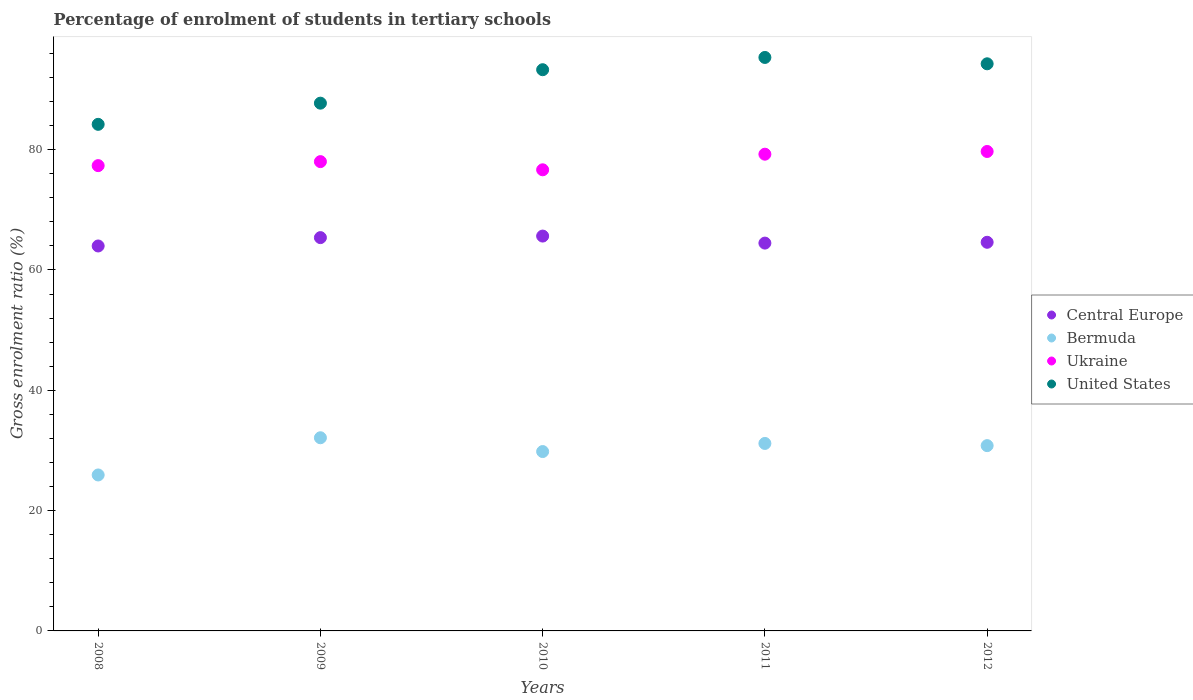How many different coloured dotlines are there?
Make the answer very short. 4. What is the percentage of students enrolled in tertiary schools in United States in 2010?
Ensure brevity in your answer.  93.29. Across all years, what is the maximum percentage of students enrolled in tertiary schools in Central Europe?
Your response must be concise. 65.64. Across all years, what is the minimum percentage of students enrolled in tertiary schools in United States?
Provide a short and direct response. 84.21. In which year was the percentage of students enrolled in tertiary schools in Central Europe minimum?
Offer a terse response. 2008. What is the total percentage of students enrolled in tertiary schools in United States in the graph?
Provide a succinct answer. 454.85. What is the difference between the percentage of students enrolled in tertiary schools in United States in 2008 and that in 2012?
Offer a terse response. -10.06. What is the difference between the percentage of students enrolled in tertiary schools in Bermuda in 2012 and the percentage of students enrolled in tertiary schools in United States in 2010?
Ensure brevity in your answer.  -62.49. What is the average percentage of students enrolled in tertiary schools in Bermuda per year?
Offer a terse response. 29.96. In the year 2010, what is the difference between the percentage of students enrolled in tertiary schools in Central Europe and percentage of students enrolled in tertiary schools in Bermuda?
Offer a very short reply. 35.82. What is the ratio of the percentage of students enrolled in tertiary schools in United States in 2009 to that in 2012?
Offer a very short reply. 0.93. Is the percentage of students enrolled in tertiary schools in Bermuda in 2009 less than that in 2010?
Make the answer very short. No. Is the difference between the percentage of students enrolled in tertiary schools in Central Europe in 2009 and 2011 greater than the difference between the percentage of students enrolled in tertiary schools in Bermuda in 2009 and 2011?
Provide a short and direct response. No. What is the difference between the highest and the second highest percentage of students enrolled in tertiary schools in Central Europe?
Provide a succinct answer. 0.26. What is the difference between the highest and the lowest percentage of students enrolled in tertiary schools in Ukraine?
Provide a succinct answer. 3.05. Is the sum of the percentage of students enrolled in tertiary schools in Bermuda in 2010 and 2011 greater than the maximum percentage of students enrolled in tertiary schools in Central Europe across all years?
Make the answer very short. No. Is it the case that in every year, the sum of the percentage of students enrolled in tertiary schools in United States and percentage of students enrolled in tertiary schools in Ukraine  is greater than the percentage of students enrolled in tertiary schools in Bermuda?
Your response must be concise. Yes. Does the percentage of students enrolled in tertiary schools in Central Europe monotonically increase over the years?
Offer a terse response. No. Is the percentage of students enrolled in tertiary schools in United States strictly greater than the percentage of students enrolled in tertiary schools in Ukraine over the years?
Offer a very short reply. Yes. How many dotlines are there?
Ensure brevity in your answer.  4. What is the difference between two consecutive major ticks on the Y-axis?
Provide a succinct answer. 20. Where does the legend appear in the graph?
Give a very brief answer. Center right. How many legend labels are there?
Your answer should be very brief. 4. How are the legend labels stacked?
Provide a short and direct response. Vertical. What is the title of the graph?
Provide a short and direct response. Percentage of enrolment of students in tertiary schools. Does "Korea (Democratic)" appear as one of the legend labels in the graph?
Your answer should be very brief. No. What is the label or title of the Y-axis?
Keep it short and to the point. Gross enrolment ratio (%). What is the Gross enrolment ratio (%) in Central Europe in 2008?
Your response must be concise. 63.99. What is the Gross enrolment ratio (%) in Bermuda in 2008?
Your response must be concise. 25.93. What is the Gross enrolment ratio (%) in Ukraine in 2008?
Offer a terse response. 77.35. What is the Gross enrolment ratio (%) of United States in 2008?
Your answer should be very brief. 84.21. What is the Gross enrolment ratio (%) in Central Europe in 2009?
Offer a very short reply. 65.38. What is the Gross enrolment ratio (%) in Bermuda in 2009?
Make the answer very short. 32.11. What is the Gross enrolment ratio (%) in Ukraine in 2009?
Make the answer very short. 78.01. What is the Gross enrolment ratio (%) in United States in 2009?
Your response must be concise. 87.73. What is the Gross enrolment ratio (%) in Central Europe in 2010?
Make the answer very short. 65.64. What is the Gross enrolment ratio (%) in Bermuda in 2010?
Your answer should be very brief. 29.82. What is the Gross enrolment ratio (%) of Ukraine in 2010?
Ensure brevity in your answer.  76.66. What is the Gross enrolment ratio (%) in United States in 2010?
Provide a short and direct response. 93.29. What is the Gross enrolment ratio (%) in Central Europe in 2011?
Provide a succinct answer. 64.47. What is the Gross enrolment ratio (%) in Bermuda in 2011?
Provide a succinct answer. 31.17. What is the Gross enrolment ratio (%) of Ukraine in 2011?
Your answer should be very brief. 79.25. What is the Gross enrolment ratio (%) of United States in 2011?
Give a very brief answer. 95.33. What is the Gross enrolment ratio (%) of Central Europe in 2012?
Your answer should be very brief. 64.61. What is the Gross enrolment ratio (%) of Bermuda in 2012?
Provide a succinct answer. 30.8. What is the Gross enrolment ratio (%) in Ukraine in 2012?
Ensure brevity in your answer.  79.7. What is the Gross enrolment ratio (%) of United States in 2012?
Offer a very short reply. 94.28. Across all years, what is the maximum Gross enrolment ratio (%) in Central Europe?
Provide a short and direct response. 65.64. Across all years, what is the maximum Gross enrolment ratio (%) of Bermuda?
Keep it short and to the point. 32.11. Across all years, what is the maximum Gross enrolment ratio (%) of Ukraine?
Offer a terse response. 79.7. Across all years, what is the maximum Gross enrolment ratio (%) in United States?
Ensure brevity in your answer.  95.33. Across all years, what is the minimum Gross enrolment ratio (%) of Central Europe?
Give a very brief answer. 63.99. Across all years, what is the minimum Gross enrolment ratio (%) of Bermuda?
Offer a very short reply. 25.93. Across all years, what is the minimum Gross enrolment ratio (%) in Ukraine?
Provide a succinct answer. 76.66. Across all years, what is the minimum Gross enrolment ratio (%) of United States?
Keep it short and to the point. 84.21. What is the total Gross enrolment ratio (%) in Central Europe in the graph?
Give a very brief answer. 324.09. What is the total Gross enrolment ratio (%) in Bermuda in the graph?
Provide a short and direct response. 149.82. What is the total Gross enrolment ratio (%) in Ukraine in the graph?
Keep it short and to the point. 390.97. What is the total Gross enrolment ratio (%) of United States in the graph?
Make the answer very short. 454.85. What is the difference between the Gross enrolment ratio (%) in Central Europe in 2008 and that in 2009?
Provide a succinct answer. -1.39. What is the difference between the Gross enrolment ratio (%) in Bermuda in 2008 and that in 2009?
Your response must be concise. -6.18. What is the difference between the Gross enrolment ratio (%) of Ukraine in 2008 and that in 2009?
Give a very brief answer. -0.67. What is the difference between the Gross enrolment ratio (%) of United States in 2008 and that in 2009?
Your answer should be very brief. -3.52. What is the difference between the Gross enrolment ratio (%) in Central Europe in 2008 and that in 2010?
Your response must be concise. -1.65. What is the difference between the Gross enrolment ratio (%) of Bermuda in 2008 and that in 2010?
Offer a very short reply. -3.89. What is the difference between the Gross enrolment ratio (%) of Ukraine in 2008 and that in 2010?
Offer a very short reply. 0.69. What is the difference between the Gross enrolment ratio (%) of United States in 2008 and that in 2010?
Provide a succinct answer. -9.08. What is the difference between the Gross enrolment ratio (%) in Central Europe in 2008 and that in 2011?
Your response must be concise. -0.48. What is the difference between the Gross enrolment ratio (%) of Bermuda in 2008 and that in 2011?
Give a very brief answer. -5.24. What is the difference between the Gross enrolment ratio (%) in Ukraine in 2008 and that in 2011?
Ensure brevity in your answer.  -1.9. What is the difference between the Gross enrolment ratio (%) in United States in 2008 and that in 2011?
Your answer should be very brief. -11.12. What is the difference between the Gross enrolment ratio (%) of Central Europe in 2008 and that in 2012?
Offer a terse response. -0.61. What is the difference between the Gross enrolment ratio (%) of Bermuda in 2008 and that in 2012?
Give a very brief answer. -4.88. What is the difference between the Gross enrolment ratio (%) of Ukraine in 2008 and that in 2012?
Give a very brief answer. -2.35. What is the difference between the Gross enrolment ratio (%) of United States in 2008 and that in 2012?
Provide a short and direct response. -10.06. What is the difference between the Gross enrolment ratio (%) in Central Europe in 2009 and that in 2010?
Your answer should be compact. -0.26. What is the difference between the Gross enrolment ratio (%) of Bermuda in 2009 and that in 2010?
Your answer should be very brief. 2.29. What is the difference between the Gross enrolment ratio (%) of Ukraine in 2009 and that in 2010?
Provide a succinct answer. 1.36. What is the difference between the Gross enrolment ratio (%) of United States in 2009 and that in 2010?
Provide a succinct answer. -5.56. What is the difference between the Gross enrolment ratio (%) of Central Europe in 2009 and that in 2011?
Provide a short and direct response. 0.91. What is the difference between the Gross enrolment ratio (%) in Bermuda in 2009 and that in 2011?
Ensure brevity in your answer.  0.95. What is the difference between the Gross enrolment ratio (%) of Ukraine in 2009 and that in 2011?
Your response must be concise. -1.23. What is the difference between the Gross enrolment ratio (%) in United States in 2009 and that in 2011?
Offer a terse response. -7.6. What is the difference between the Gross enrolment ratio (%) in Central Europe in 2009 and that in 2012?
Ensure brevity in your answer.  0.78. What is the difference between the Gross enrolment ratio (%) of Bermuda in 2009 and that in 2012?
Keep it short and to the point. 1.31. What is the difference between the Gross enrolment ratio (%) in Ukraine in 2009 and that in 2012?
Give a very brief answer. -1.69. What is the difference between the Gross enrolment ratio (%) of United States in 2009 and that in 2012?
Make the answer very short. -6.54. What is the difference between the Gross enrolment ratio (%) in Central Europe in 2010 and that in 2011?
Ensure brevity in your answer.  1.17. What is the difference between the Gross enrolment ratio (%) in Bermuda in 2010 and that in 2011?
Your answer should be very brief. -1.35. What is the difference between the Gross enrolment ratio (%) of Ukraine in 2010 and that in 2011?
Offer a terse response. -2.59. What is the difference between the Gross enrolment ratio (%) in United States in 2010 and that in 2011?
Your response must be concise. -2.04. What is the difference between the Gross enrolment ratio (%) of Central Europe in 2010 and that in 2012?
Make the answer very short. 1.03. What is the difference between the Gross enrolment ratio (%) in Bermuda in 2010 and that in 2012?
Offer a very short reply. -0.99. What is the difference between the Gross enrolment ratio (%) of Ukraine in 2010 and that in 2012?
Offer a terse response. -3.05. What is the difference between the Gross enrolment ratio (%) in United States in 2010 and that in 2012?
Make the answer very short. -0.98. What is the difference between the Gross enrolment ratio (%) of Central Europe in 2011 and that in 2012?
Offer a very short reply. -0.14. What is the difference between the Gross enrolment ratio (%) of Bermuda in 2011 and that in 2012?
Provide a succinct answer. 0.36. What is the difference between the Gross enrolment ratio (%) of Ukraine in 2011 and that in 2012?
Your response must be concise. -0.45. What is the difference between the Gross enrolment ratio (%) of United States in 2011 and that in 2012?
Your response must be concise. 1.06. What is the difference between the Gross enrolment ratio (%) of Central Europe in 2008 and the Gross enrolment ratio (%) of Bermuda in 2009?
Your response must be concise. 31.88. What is the difference between the Gross enrolment ratio (%) in Central Europe in 2008 and the Gross enrolment ratio (%) in Ukraine in 2009?
Offer a very short reply. -14.02. What is the difference between the Gross enrolment ratio (%) in Central Europe in 2008 and the Gross enrolment ratio (%) in United States in 2009?
Your answer should be compact. -23.74. What is the difference between the Gross enrolment ratio (%) of Bermuda in 2008 and the Gross enrolment ratio (%) of Ukraine in 2009?
Provide a short and direct response. -52.09. What is the difference between the Gross enrolment ratio (%) of Bermuda in 2008 and the Gross enrolment ratio (%) of United States in 2009?
Your answer should be compact. -61.81. What is the difference between the Gross enrolment ratio (%) of Ukraine in 2008 and the Gross enrolment ratio (%) of United States in 2009?
Provide a succinct answer. -10.38. What is the difference between the Gross enrolment ratio (%) in Central Europe in 2008 and the Gross enrolment ratio (%) in Bermuda in 2010?
Provide a short and direct response. 34.17. What is the difference between the Gross enrolment ratio (%) of Central Europe in 2008 and the Gross enrolment ratio (%) of Ukraine in 2010?
Your answer should be compact. -12.66. What is the difference between the Gross enrolment ratio (%) in Central Europe in 2008 and the Gross enrolment ratio (%) in United States in 2010?
Make the answer very short. -29.3. What is the difference between the Gross enrolment ratio (%) in Bermuda in 2008 and the Gross enrolment ratio (%) in Ukraine in 2010?
Your answer should be compact. -50.73. What is the difference between the Gross enrolment ratio (%) in Bermuda in 2008 and the Gross enrolment ratio (%) in United States in 2010?
Your answer should be compact. -67.37. What is the difference between the Gross enrolment ratio (%) in Ukraine in 2008 and the Gross enrolment ratio (%) in United States in 2010?
Offer a very short reply. -15.94. What is the difference between the Gross enrolment ratio (%) of Central Europe in 2008 and the Gross enrolment ratio (%) of Bermuda in 2011?
Offer a terse response. 32.83. What is the difference between the Gross enrolment ratio (%) of Central Europe in 2008 and the Gross enrolment ratio (%) of Ukraine in 2011?
Make the answer very short. -15.26. What is the difference between the Gross enrolment ratio (%) in Central Europe in 2008 and the Gross enrolment ratio (%) in United States in 2011?
Offer a very short reply. -31.34. What is the difference between the Gross enrolment ratio (%) in Bermuda in 2008 and the Gross enrolment ratio (%) in Ukraine in 2011?
Offer a terse response. -53.32. What is the difference between the Gross enrolment ratio (%) in Bermuda in 2008 and the Gross enrolment ratio (%) in United States in 2011?
Offer a very short reply. -69.41. What is the difference between the Gross enrolment ratio (%) in Ukraine in 2008 and the Gross enrolment ratio (%) in United States in 2011?
Keep it short and to the point. -17.98. What is the difference between the Gross enrolment ratio (%) of Central Europe in 2008 and the Gross enrolment ratio (%) of Bermuda in 2012?
Provide a short and direct response. 33.19. What is the difference between the Gross enrolment ratio (%) in Central Europe in 2008 and the Gross enrolment ratio (%) in Ukraine in 2012?
Provide a succinct answer. -15.71. What is the difference between the Gross enrolment ratio (%) in Central Europe in 2008 and the Gross enrolment ratio (%) in United States in 2012?
Your response must be concise. -30.29. What is the difference between the Gross enrolment ratio (%) in Bermuda in 2008 and the Gross enrolment ratio (%) in Ukraine in 2012?
Your answer should be compact. -53.78. What is the difference between the Gross enrolment ratio (%) of Bermuda in 2008 and the Gross enrolment ratio (%) of United States in 2012?
Offer a very short reply. -68.35. What is the difference between the Gross enrolment ratio (%) of Ukraine in 2008 and the Gross enrolment ratio (%) of United States in 2012?
Ensure brevity in your answer.  -16.93. What is the difference between the Gross enrolment ratio (%) of Central Europe in 2009 and the Gross enrolment ratio (%) of Bermuda in 2010?
Give a very brief answer. 35.56. What is the difference between the Gross enrolment ratio (%) of Central Europe in 2009 and the Gross enrolment ratio (%) of Ukraine in 2010?
Provide a succinct answer. -11.27. What is the difference between the Gross enrolment ratio (%) of Central Europe in 2009 and the Gross enrolment ratio (%) of United States in 2010?
Offer a very short reply. -27.91. What is the difference between the Gross enrolment ratio (%) in Bermuda in 2009 and the Gross enrolment ratio (%) in Ukraine in 2010?
Give a very brief answer. -44.54. What is the difference between the Gross enrolment ratio (%) in Bermuda in 2009 and the Gross enrolment ratio (%) in United States in 2010?
Give a very brief answer. -61.18. What is the difference between the Gross enrolment ratio (%) in Ukraine in 2009 and the Gross enrolment ratio (%) in United States in 2010?
Your answer should be very brief. -15.28. What is the difference between the Gross enrolment ratio (%) of Central Europe in 2009 and the Gross enrolment ratio (%) of Bermuda in 2011?
Offer a terse response. 34.22. What is the difference between the Gross enrolment ratio (%) of Central Europe in 2009 and the Gross enrolment ratio (%) of Ukraine in 2011?
Your answer should be compact. -13.87. What is the difference between the Gross enrolment ratio (%) in Central Europe in 2009 and the Gross enrolment ratio (%) in United States in 2011?
Offer a terse response. -29.95. What is the difference between the Gross enrolment ratio (%) in Bermuda in 2009 and the Gross enrolment ratio (%) in Ukraine in 2011?
Provide a short and direct response. -47.14. What is the difference between the Gross enrolment ratio (%) of Bermuda in 2009 and the Gross enrolment ratio (%) of United States in 2011?
Your answer should be compact. -63.22. What is the difference between the Gross enrolment ratio (%) in Ukraine in 2009 and the Gross enrolment ratio (%) in United States in 2011?
Ensure brevity in your answer.  -17.32. What is the difference between the Gross enrolment ratio (%) of Central Europe in 2009 and the Gross enrolment ratio (%) of Bermuda in 2012?
Provide a short and direct response. 34.58. What is the difference between the Gross enrolment ratio (%) in Central Europe in 2009 and the Gross enrolment ratio (%) in Ukraine in 2012?
Your response must be concise. -14.32. What is the difference between the Gross enrolment ratio (%) in Central Europe in 2009 and the Gross enrolment ratio (%) in United States in 2012?
Your answer should be compact. -28.9. What is the difference between the Gross enrolment ratio (%) of Bermuda in 2009 and the Gross enrolment ratio (%) of Ukraine in 2012?
Your answer should be compact. -47.59. What is the difference between the Gross enrolment ratio (%) in Bermuda in 2009 and the Gross enrolment ratio (%) in United States in 2012?
Your answer should be very brief. -62.17. What is the difference between the Gross enrolment ratio (%) of Ukraine in 2009 and the Gross enrolment ratio (%) of United States in 2012?
Ensure brevity in your answer.  -16.26. What is the difference between the Gross enrolment ratio (%) of Central Europe in 2010 and the Gross enrolment ratio (%) of Bermuda in 2011?
Ensure brevity in your answer.  34.47. What is the difference between the Gross enrolment ratio (%) of Central Europe in 2010 and the Gross enrolment ratio (%) of Ukraine in 2011?
Make the answer very short. -13.61. What is the difference between the Gross enrolment ratio (%) of Central Europe in 2010 and the Gross enrolment ratio (%) of United States in 2011?
Offer a terse response. -29.69. What is the difference between the Gross enrolment ratio (%) of Bermuda in 2010 and the Gross enrolment ratio (%) of Ukraine in 2011?
Make the answer very short. -49.43. What is the difference between the Gross enrolment ratio (%) of Bermuda in 2010 and the Gross enrolment ratio (%) of United States in 2011?
Your answer should be very brief. -65.52. What is the difference between the Gross enrolment ratio (%) in Ukraine in 2010 and the Gross enrolment ratio (%) in United States in 2011?
Offer a very short reply. -18.68. What is the difference between the Gross enrolment ratio (%) of Central Europe in 2010 and the Gross enrolment ratio (%) of Bermuda in 2012?
Your answer should be very brief. 34.84. What is the difference between the Gross enrolment ratio (%) in Central Europe in 2010 and the Gross enrolment ratio (%) in Ukraine in 2012?
Your answer should be compact. -14.06. What is the difference between the Gross enrolment ratio (%) of Central Europe in 2010 and the Gross enrolment ratio (%) of United States in 2012?
Give a very brief answer. -28.64. What is the difference between the Gross enrolment ratio (%) of Bermuda in 2010 and the Gross enrolment ratio (%) of Ukraine in 2012?
Offer a terse response. -49.88. What is the difference between the Gross enrolment ratio (%) in Bermuda in 2010 and the Gross enrolment ratio (%) in United States in 2012?
Give a very brief answer. -64.46. What is the difference between the Gross enrolment ratio (%) of Ukraine in 2010 and the Gross enrolment ratio (%) of United States in 2012?
Ensure brevity in your answer.  -17.62. What is the difference between the Gross enrolment ratio (%) of Central Europe in 2011 and the Gross enrolment ratio (%) of Bermuda in 2012?
Give a very brief answer. 33.67. What is the difference between the Gross enrolment ratio (%) of Central Europe in 2011 and the Gross enrolment ratio (%) of Ukraine in 2012?
Keep it short and to the point. -15.23. What is the difference between the Gross enrolment ratio (%) in Central Europe in 2011 and the Gross enrolment ratio (%) in United States in 2012?
Make the answer very short. -29.81. What is the difference between the Gross enrolment ratio (%) of Bermuda in 2011 and the Gross enrolment ratio (%) of Ukraine in 2012?
Your answer should be compact. -48.54. What is the difference between the Gross enrolment ratio (%) of Bermuda in 2011 and the Gross enrolment ratio (%) of United States in 2012?
Ensure brevity in your answer.  -63.11. What is the difference between the Gross enrolment ratio (%) in Ukraine in 2011 and the Gross enrolment ratio (%) in United States in 2012?
Your answer should be very brief. -15.03. What is the average Gross enrolment ratio (%) in Central Europe per year?
Keep it short and to the point. 64.82. What is the average Gross enrolment ratio (%) of Bermuda per year?
Provide a short and direct response. 29.96. What is the average Gross enrolment ratio (%) of Ukraine per year?
Your answer should be compact. 78.19. What is the average Gross enrolment ratio (%) in United States per year?
Give a very brief answer. 90.97. In the year 2008, what is the difference between the Gross enrolment ratio (%) of Central Europe and Gross enrolment ratio (%) of Bermuda?
Keep it short and to the point. 38.07. In the year 2008, what is the difference between the Gross enrolment ratio (%) of Central Europe and Gross enrolment ratio (%) of Ukraine?
Offer a terse response. -13.36. In the year 2008, what is the difference between the Gross enrolment ratio (%) of Central Europe and Gross enrolment ratio (%) of United States?
Your response must be concise. -20.22. In the year 2008, what is the difference between the Gross enrolment ratio (%) in Bermuda and Gross enrolment ratio (%) in Ukraine?
Your answer should be very brief. -51.42. In the year 2008, what is the difference between the Gross enrolment ratio (%) of Bermuda and Gross enrolment ratio (%) of United States?
Keep it short and to the point. -58.29. In the year 2008, what is the difference between the Gross enrolment ratio (%) in Ukraine and Gross enrolment ratio (%) in United States?
Provide a short and direct response. -6.86. In the year 2009, what is the difference between the Gross enrolment ratio (%) in Central Europe and Gross enrolment ratio (%) in Bermuda?
Your answer should be very brief. 33.27. In the year 2009, what is the difference between the Gross enrolment ratio (%) in Central Europe and Gross enrolment ratio (%) in Ukraine?
Provide a short and direct response. -12.63. In the year 2009, what is the difference between the Gross enrolment ratio (%) in Central Europe and Gross enrolment ratio (%) in United States?
Provide a succinct answer. -22.35. In the year 2009, what is the difference between the Gross enrolment ratio (%) of Bermuda and Gross enrolment ratio (%) of Ukraine?
Keep it short and to the point. -45.9. In the year 2009, what is the difference between the Gross enrolment ratio (%) in Bermuda and Gross enrolment ratio (%) in United States?
Give a very brief answer. -55.62. In the year 2009, what is the difference between the Gross enrolment ratio (%) of Ukraine and Gross enrolment ratio (%) of United States?
Make the answer very short. -9.72. In the year 2010, what is the difference between the Gross enrolment ratio (%) of Central Europe and Gross enrolment ratio (%) of Bermuda?
Provide a short and direct response. 35.82. In the year 2010, what is the difference between the Gross enrolment ratio (%) of Central Europe and Gross enrolment ratio (%) of Ukraine?
Your response must be concise. -11.02. In the year 2010, what is the difference between the Gross enrolment ratio (%) in Central Europe and Gross enrolment ratio (%) in United States?
Offer a terse response. -27.65. In the year 2010, what is the difference between the Gross enrolment ratio (%) in Bermuda and Gross enrolment ratio (%) in Ukraine?
Your answer should be compact. -46.84. In the year 2010, what is the difference between the Gross enrolment ratio (%) in Bermuda and Gross enrolment ratio (%) in United States?
Offer a very short reply. -63.48. In the year 2010, what is the difference between the Gross enrolment ratio (%) of Ukraine and Gross enrolment ratio (%) of United States?
Your answer should be compact. -16.64. In the year 2011, what is the difference between the Gross enrolment ratio (%) in Central Europe and Gross enrolment ratio (%) in Bermuda?
Keep it short and to the point. 33.3. In the year 2011, what is the difference between the Gross enrolment ratio (%) of Central Europe and Gross enrolment ratio (%) of Ukraine?
Offer a very short reply. -14.78. In the year 2011, what is the difference between the Gross enrolment ratio (%) of Central Europe and Gross enrolment ratio (%) of United States?
Offer a terse response. -30.86. In the year 2011, what is the difference between the Gross enrolment ratio (%) in Bermuda and Gross enrolment ratio (%) in Ukraine?
Your response must be concise. -48.08. In the year 2011, what is the difference between the Gross enrolment ratio (%) of Bermuda and Gross enrolment ratio (%) of United States?
Make the answer very short. -64.17. In the year 2011, what is the difference between the Gross enrolment ratio (%) in Ukraine and Gross enrolment ratio (%) in United States?
Ensure brevity in your answer.  -16.08. In the year 2012, what is the difference between the Gross enrolment ratio (%) in Central Europe and Gross enrolment ratio (%) in Bermuda?
Your response must be concise. 33.8. In the year 2012, what is the difference between the Gross enrolment ratio (%) in Central Europe and Gross enrolment ratio (%) in Ukraine?
Your response must be concise. -15.1. In the year 2012, what is the difference between the Gross enrolment ratio (%) in Central Europe and Gross enrolment ratio (%) in United States?
Ensure brevity in your answer.  -29.67. In the year 2012, what is the difference between the Gross enrolment ratio (%) in Bermuda and Gross enrolment ratio (%) in Ukraine?
Provide a short and direct response. -48.9. In the year 2012, what is the difference between the Gross enrolment ratio (%) of Bermuda and Gross enrolment ratio (%) of United States?
Ensure brevity in your answer.  -63.47. In the year 2012, what is the difference between the Gross enrolment ratio (%) of Ukraine and Gross enrolment ratio (%) of United States?
Your response must be concise. -14.58. What is the ratio of the Gross enrolment ratio (%) in Central Europe in 2008 to that in 2009?
Provide a succinct answer. 0.98. What is the ratio of the Gross enrolment ratio (%) of Bermuda in 2008 to that in 2009?
Provide a succinct answer. 0.81. What is the ratio of the Gross enrolment ratio (%) of Ukraine in 2008 to that in 2009?
Your answer should be compact. 0.99. What is the ratio of the Gross enrolment ratio (%) of United States in 2008 to that in 2009?
Offer a terse response. 0.96. What is the ratio of the Gross enrolment ratio (%) in Central Europe in 2008 to that in 2010?
Make the answer very short. 0.97. What is the ratio of the Gross enrolment ratio (%) of Bermuda in 2008 to that in 2010?
Offer a very short reply. 0.87. What is the ratio of the Gross enrolment ratio (%) of Ukraine in 2008 to that in 2010?
Keep it short and to the point. 1.01. What is the ratio of the Gross enrolment ratio (%) of United States in 2008 to that in 2010?
Make the answer very short. 0.9. What is the ratio of the Gross enrolment ratio (%) of Bermuda in 2008 to that in 2011?
Make the answer very short. 0.83. What is the ratio of the Gross enrolment ratio (%) of United States in 2008 to that in 2011?
Keep it short and to the point. 0.88. What is the ratio of the Gross enrolment ratio (%) in Bermuda in 2008 to that in 2012?
Offer a terse response. 0.84. What is the ratio of the Gross enrolment ratio (%) in Ukraine in 2008 to that in 2012?
Ensure brevity in your answer.  0.97. What is the ratio of the Gross enrolment ratio (%) of United States in 2008 to that in 2012?
Give a very brief answer. 0.89. What is the ratio of the Gross enrolment ratio (%) in Bermuda in 2009 to that in 2010?
Your answer should be compact. 1.08. What is the ratio of the Gross enrolment ratio (%) of Ukraine in 2009 to that in 2010?
Your answer should be compact. 1.02. What is the ratio of the Gross enrolment ratio (%) in United States in 2009 to that in 2010?
Provide a short and direct response. 0.94. What is the ratio of the Gross enrolment ratio (%) of Central Europe in 2009 to that in 2011?
Make the answer very short. 1.01. What is the ratio of the Gross enrolment ratio (%) in Bermuda in 2009 to that in 2011?
Your answer should be compact. 1.03. What is the ratio of the Gross enrolment ratio (%) of Ukraine in 2009 to that in 2011?
Offer a very short reply. 0.98. What is the ratio of the Gross enrolment ratio (%) in United States in 2009 to that in 2011?
Your response must be concise. 0.92. What is the ratio of the Gross enrolment ratio (%) in Central Europe in 2009 to that in 2012?
Give a very brief answer. 1.01. What is the ratio of the Gross enrolment ratio (%) of Bermuda in 2009 to that in 2012?
Offer a very short reply. 1.04. What is the ratio of the Gross enrolment ratio (%) of Ukraine in 2009 to that in 2012?
Your answer should be compact. 0.98. What is the ratio of the Gross enrolment ratio (%) of United States in 2009 to that in 2012?
Your response must be concise. 0.93. What is the ratio of the Gross enrolment ratio (%) in Central Europe in 2010 to that in 2011?
Provide a short and direct response. 1.02. What is the ratio of the Gross enrolment ratio (%) of Bermuda in 2010 to that in 2011?
Ensure brevity in your answer.  0.96. What is the ratio of the Gross enrolment ratio (%) of Ukraine in 2010 to that in 2011?
Offer a very short reply. 0.97. What is the ratio of the Gross enrolment ratio (%) of United States in 2010 to that in 2011?
Provide a succinct answer. 0.98. What is the ratio of the Gross enrolment ratio (%) of Central Europe in 2010 to that in 2012?
Offer a very short reply. 1.02. What is the ratio of the Gross enrolment ratio (%) in Ukraine in 2010 to that in 2012?
Your answer should be compact. 0.96. What is the ratio of the Gross enrolment ratio (%) of United States in 2010 to that in 2012?
Ensure brevity in your answer.  0.99. What is the ratio of the Gross enrolment ratio (%) in Central Europe in 2011 to that in 2012?
Offer a terse response. 1. What is the ratio of the Gross enrolment ratio (%) of Bermuda in 2011 to that in 2012?
Your response must be concise. 1.01. What is the ratio of the Gross enrolment ratio (%) of Ukraine in 2011 to that in 2012?
Offer a terse response. 0.99. What is the ratio of the Gross enrolment ratio (%) in United States in 2011 to that in 2012?
Offer a terse response. 1.01. What is the difference between the highest and the second highest Gross enrolment ratio (%) of Central Europe?
Keep it short and to the point. 0.26. What is the difference between the highest and the second highest Gross enrolment ratio (%) in Bermuda?
Your answer should be very brief. 0.95. What is the difference between the highest and the second highest Gross enrolment ratio (%) in Ukraine?
Provide a succinct answer. 0.45. What is the difference between the highest and the second highest Gross enrolment ratio (%) of United States?
Provide a succinct answer. 1.06. What is the difference between the highest and the lowest Gross enrolment ratio (%) of Central Europe?
Make the answer very short. 1.65. What is the difference between the highest and the lowest Gross enrolment ratio (%) of Bermuda?
Offer a very short reply. 6.18. What is the difference between the highest and the lowest Gross enrolment ratio (%) in Ukraine?
Give a very brief answer. 3.05. What is the difference between the highest and the lowest Gross enrolment ratio (%) of United States?
Your answer should be compact. 11.12. 